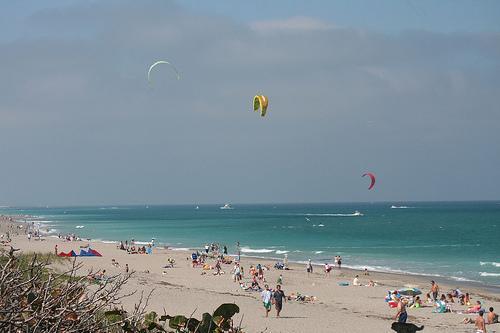How many things are in the sky?
Give a very brief answer. 3. 